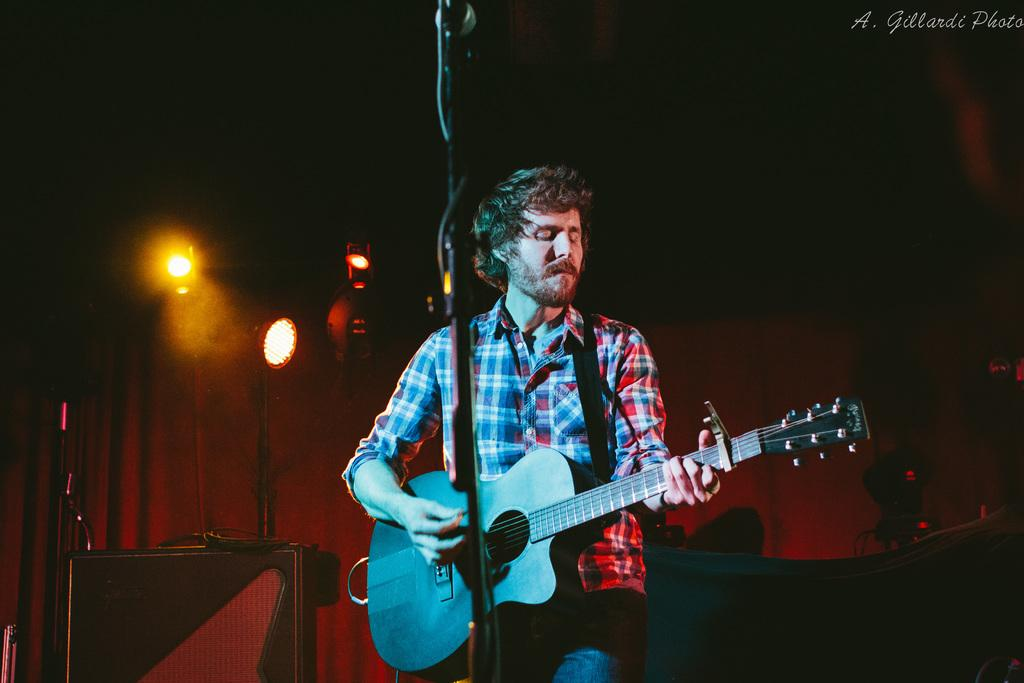What is the man in the image doing? The man is playing the guitar. What is the man wearing in the image? The man is wearing a checkered shirt. What object is the man holding in the image? The man is holding a guitar. What is in front of the man in the image? There is a microphone and a microphone stand in front of the man. What can be seen in the background of the image? There are lights, a table, and a curtain in the background of the image. What type of glove is the man wearing in the image? The man is not wearing a glove in the image; he is wearing a checkered shirt. What type of hook is attached to the microphone stand in the image? There is no hook attached to the microphone stand in the image. 